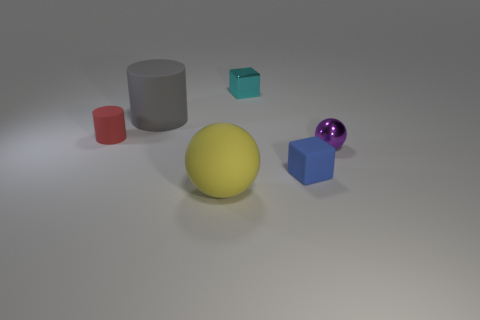Add 4 tiny rubber balls. How many objects exist? 10 Subtract all spheres. How many objects are left? 4 Add 1 blue matte things. How many blue matte things are left? 2 Add 5 big gray rubber things. How many big gray rubber things exist? 6 Subtract 1 gray cylinders. How many objects are left? 5 Subtract all tiny cylinders. Subtract all big gray objects. How many objects are left? 4 